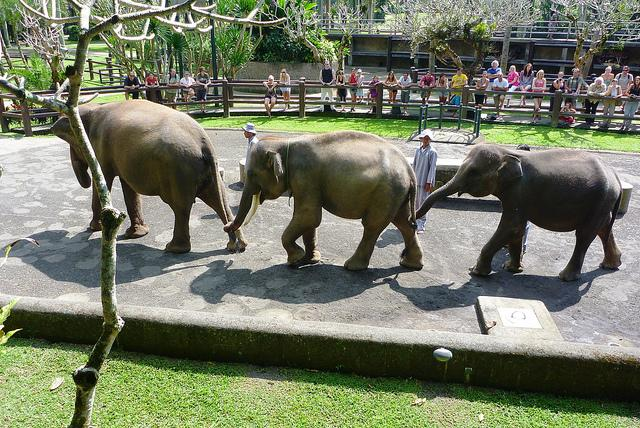What direction are the elephants marching? Please explain your reasoning. west. The elephants are heading the left, which is west. 